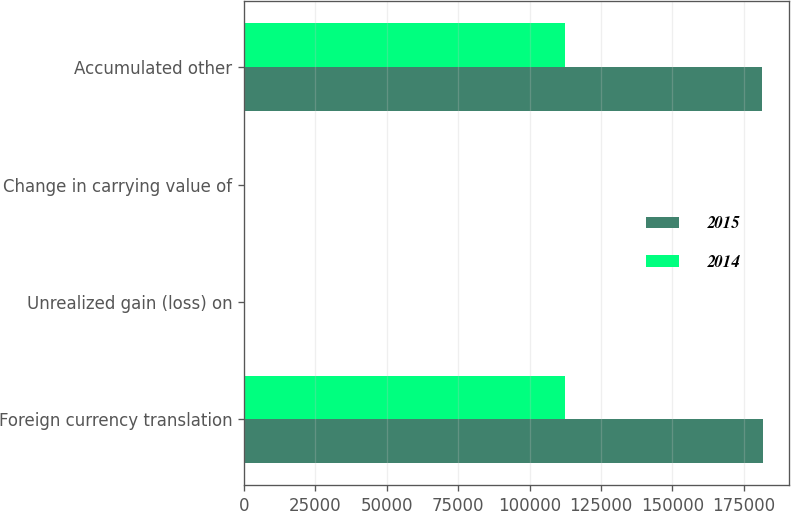Convert chart to OTSL. <chart><loc_0><loc_0><loc_500><loc_500><stacked_bar_chart><ecel><fcel>Foreign currency translation<fcel>Unrealized gain (loss) on<fcel>Change in carrying value of<fcel>Accumulated other<nl><fcel>2015<fcel>181725<fcel>11<fcel>232<fcel>181482<nl><fcel>2014<fcel>112411<fcel>84<fcel>232<fcel>112263<nl></chart> 